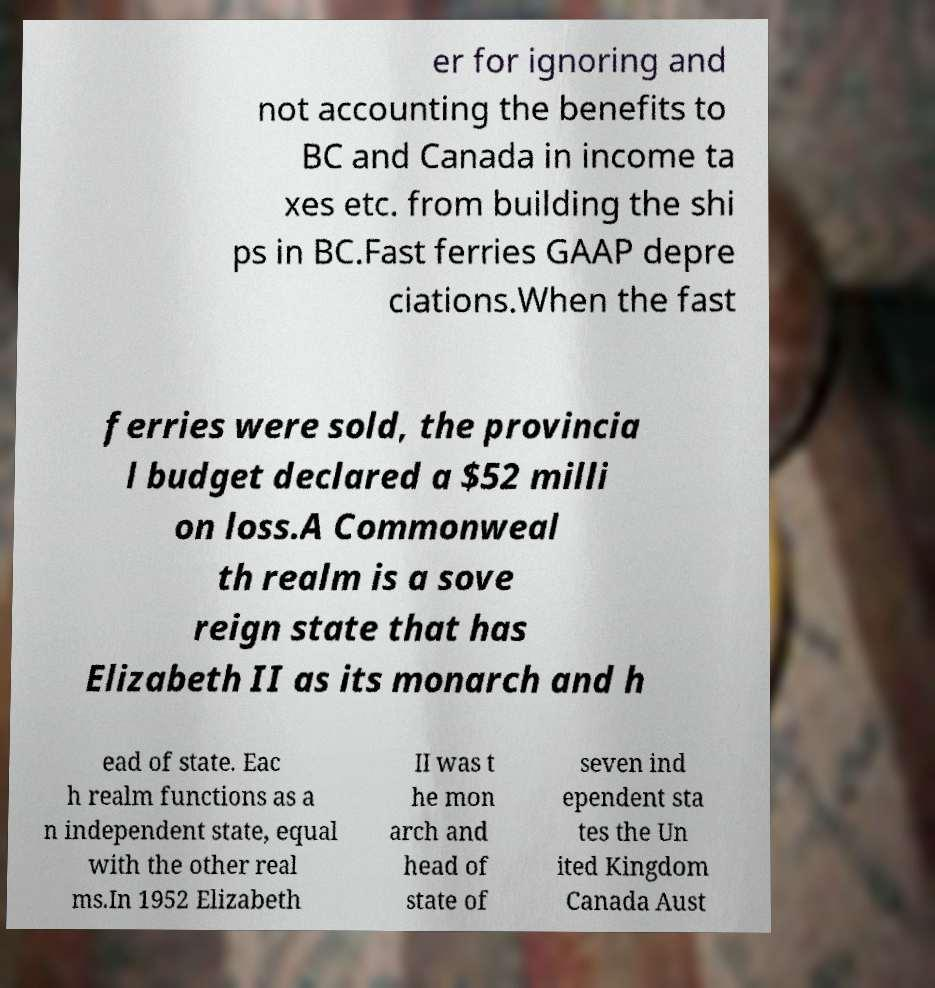What messages or text are displayed in this image? I need them in a readable, typed format. er for ignoring and not accounting the benefits to BC and Canada in income ta xes etc. from building the shi ps in BC.Fast ferries GAAP depre ciations.When the fast ferries were sold, the provincia l budget declared a $52 milli on loss.A Commonweal th realm is a sove reign state that has Elizabeth II as its monarch and h ead of state. Eac h realm functions as a n independent state, equal with the other real ms.In 1952 Elizabeth II was t he mon arch and head of state of seven ind ependent sta tes the Un ited Kingdom Canada Aust 